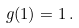<formula> <loc_0><loc_0><loc_500><loc_500>g ( 1 ) = 1 \, .</formula> 